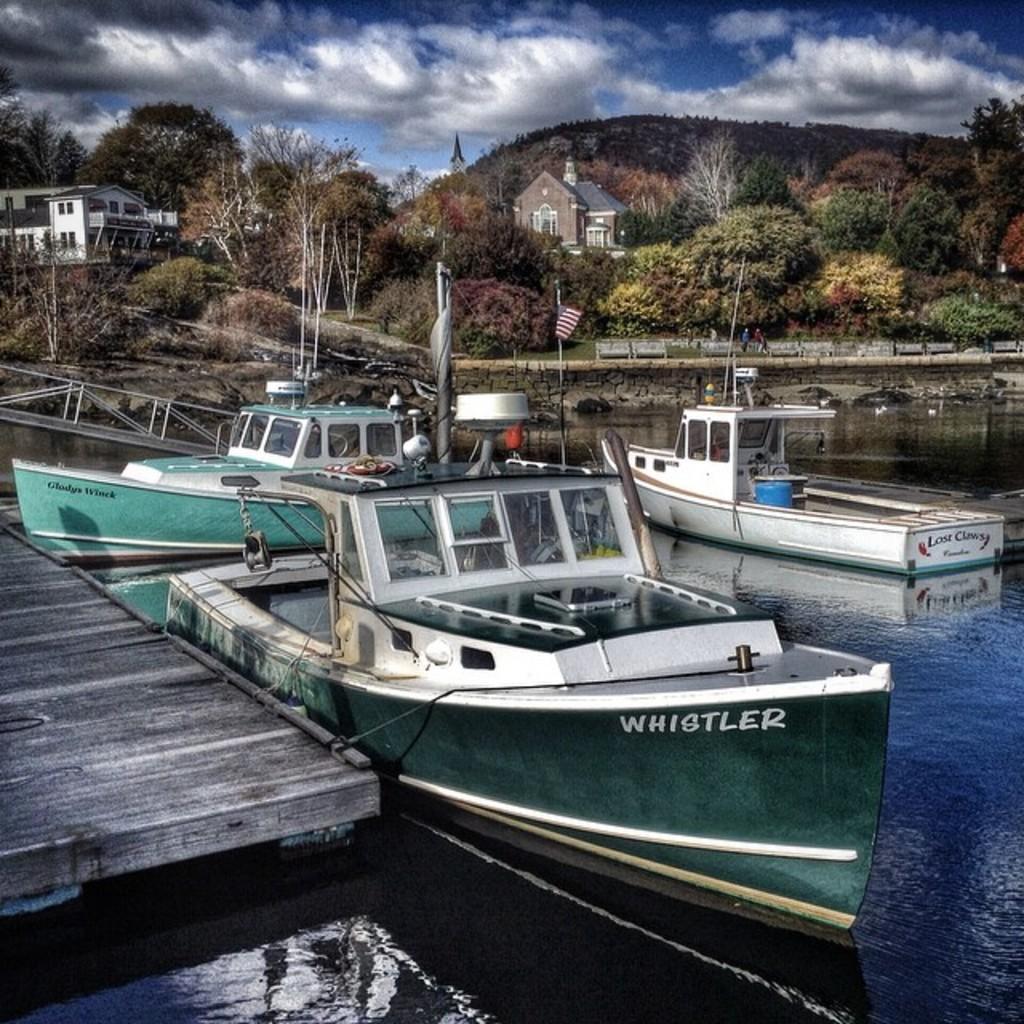Can you describe this image briefly? In the image we can see there are many boats in the water. This is a wooden surface, grass, trees, path, mountain, the flag of a country and a cloudy sky. We can see there are even buildings. 